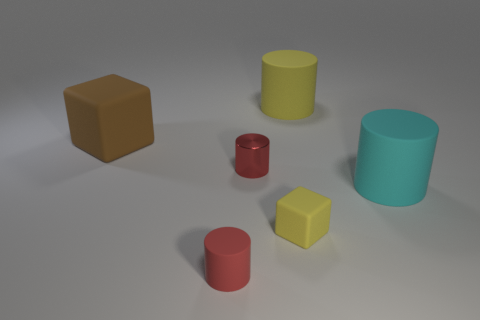Subtract all metallic cylinders. How many cylinders are left? 3 Add 4 big rubber cubes. How many objects exist? 10 Subtract all cyan cylinders. How many cylinders are left? 3 Subtract all blocks. How many objects are left? 4 Subtract all tiny green metallic cylinders. Subtract all yellow objects. How many objects are left? 4 Add 5 small matte cylinders. How many small matte cylinders are left? 6 Add 3 small red matte cylinders. How many small red matte cylinders exist? 4 Subtract 0 purple balls. How many objects are left? 6 Subtract 2 blocks. How many blocks are left? 0 Subtract all brown cylinders. Subtract all red balls. How many cylinders are left? 4 